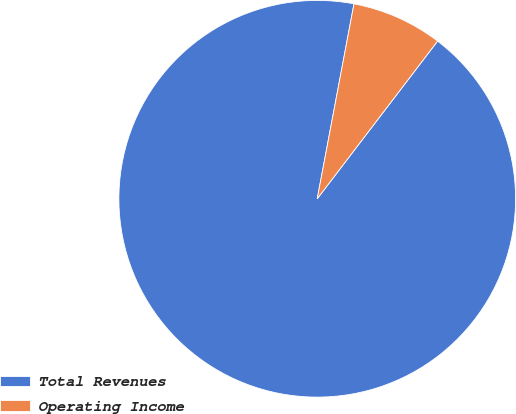<chart> <loc_0><loc_0><loc_500><loc_500><pie_chart><fcel>Total Revenues<fcel>Operating Income<nl><fcel>92.59%<fcel>7.41%<nl></chart> 